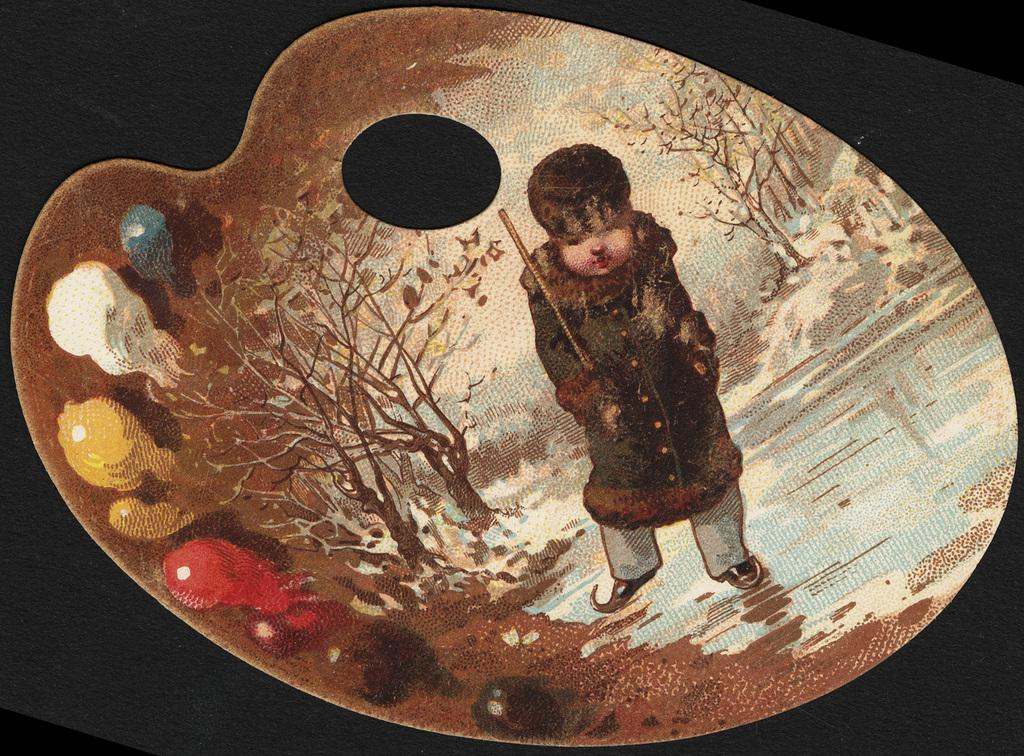What type of image is being described? The image is an art piece. Who or what is depicted in the art? There is a little boy in the art. What is the little boy doing in the art? The little boy is walking. What is the little boy wearing in the art? The little boy is wearing a coat. What type of vest can be seen on the little boy in the art? There is no vest mentioned in the provided facts, and the little boy is wearing a coat. 